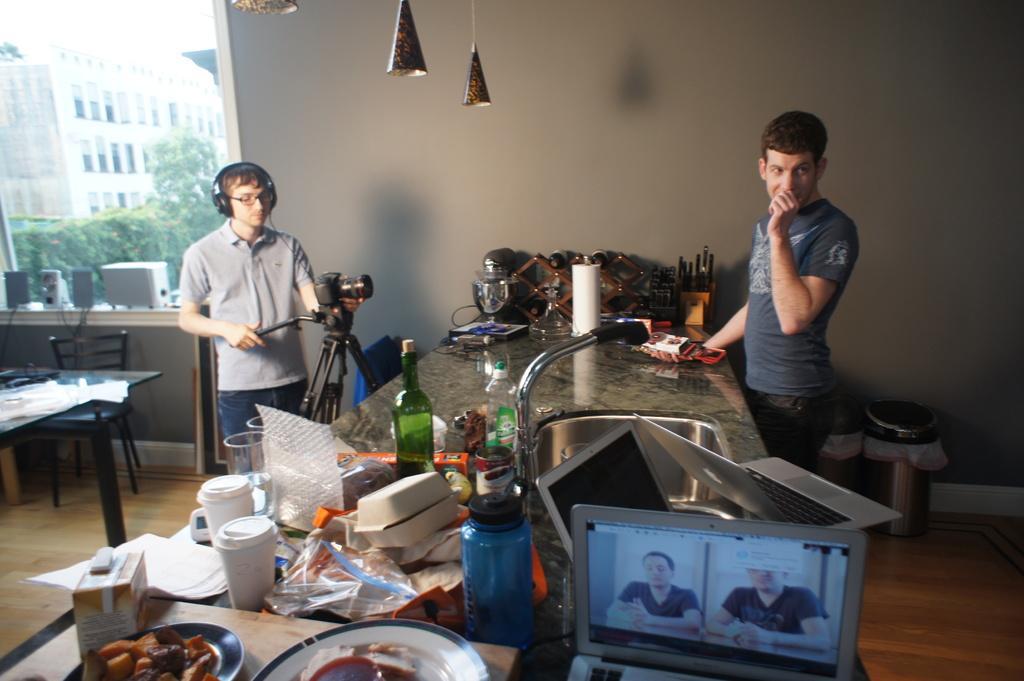Could you give a brief overview of what you see in this image? In this there are the two persons stand in front of a table , and there are the bottles and food items and laptops and some other objects kept on the table an back side of them there is a building and there are some trees visible on the left side corner. 